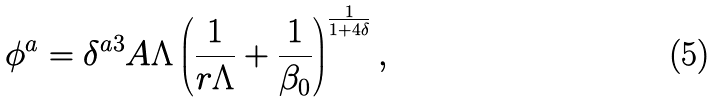Convert formula to latex. <formula><loc_0><loc_0><loc_500><loc_500>\phi ^ { a } = \delta ^ { a 3 } A \Lambda \left ( \frac { 1 } { r \Lambda } + \frac { 1 } { \beta _ { 0 } } \right ) ^ { \frac { 1 } { 1 + 4 \delta } } ,</formula> 